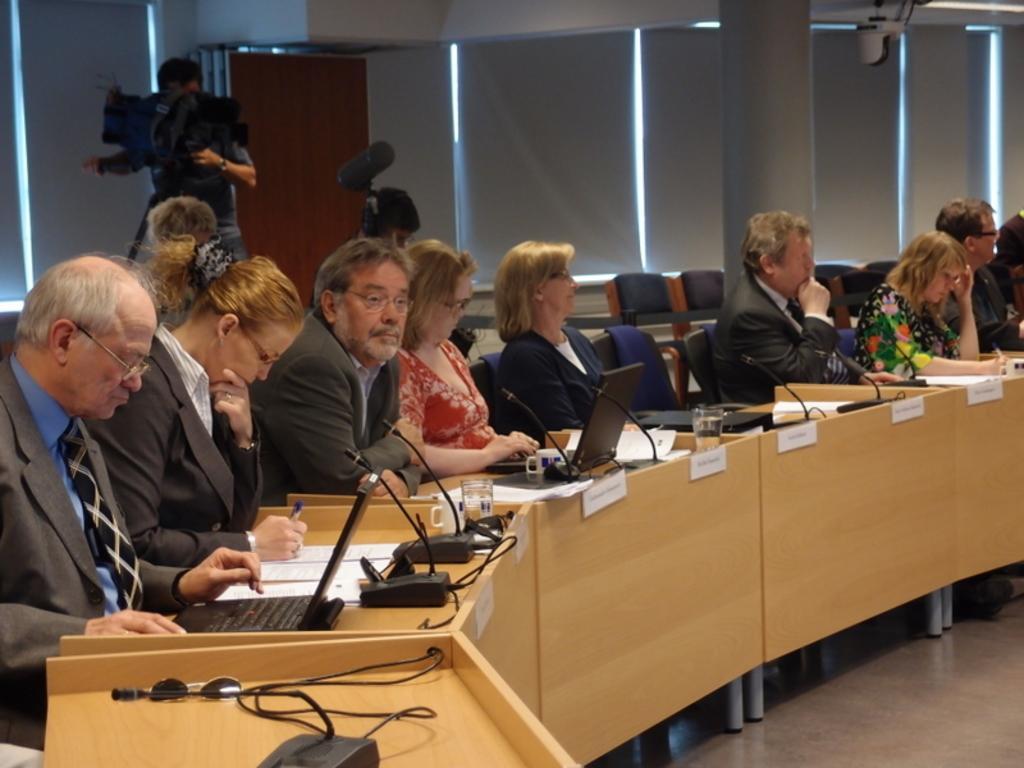Can you describe this image briefly? In this image we can see a group of people sitting on the chairs beside a table containing some glasses, laptops, wires, some mics with the stand, spectacles, the name boards and some papers on it. In that two women are holding the pens. On the backside we can see a person standing holding a camera with a stand, a person holding the micro phone, a pillar, curtain blinds and some ceiling lights to a roof. 